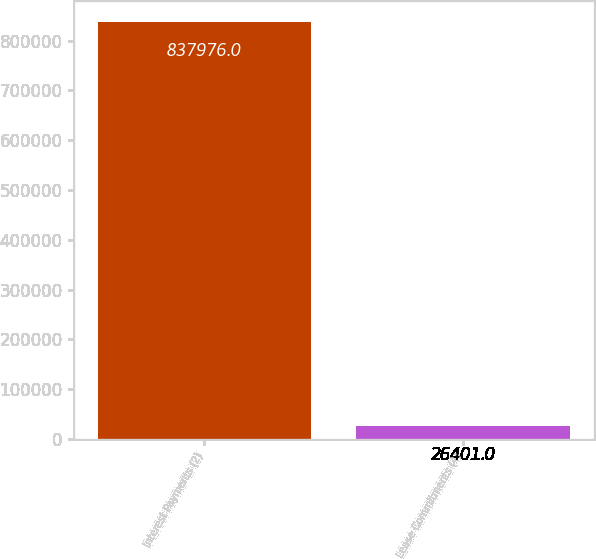Convert chart to OTSL. <chart><loc_0><loc_0><loc_500><loc_500><bar_chart><fcel>Interest Payments (2)<fcel>Lease Commitments (4)<nl><fcel>837976<fcel>26401<nl></chart> 